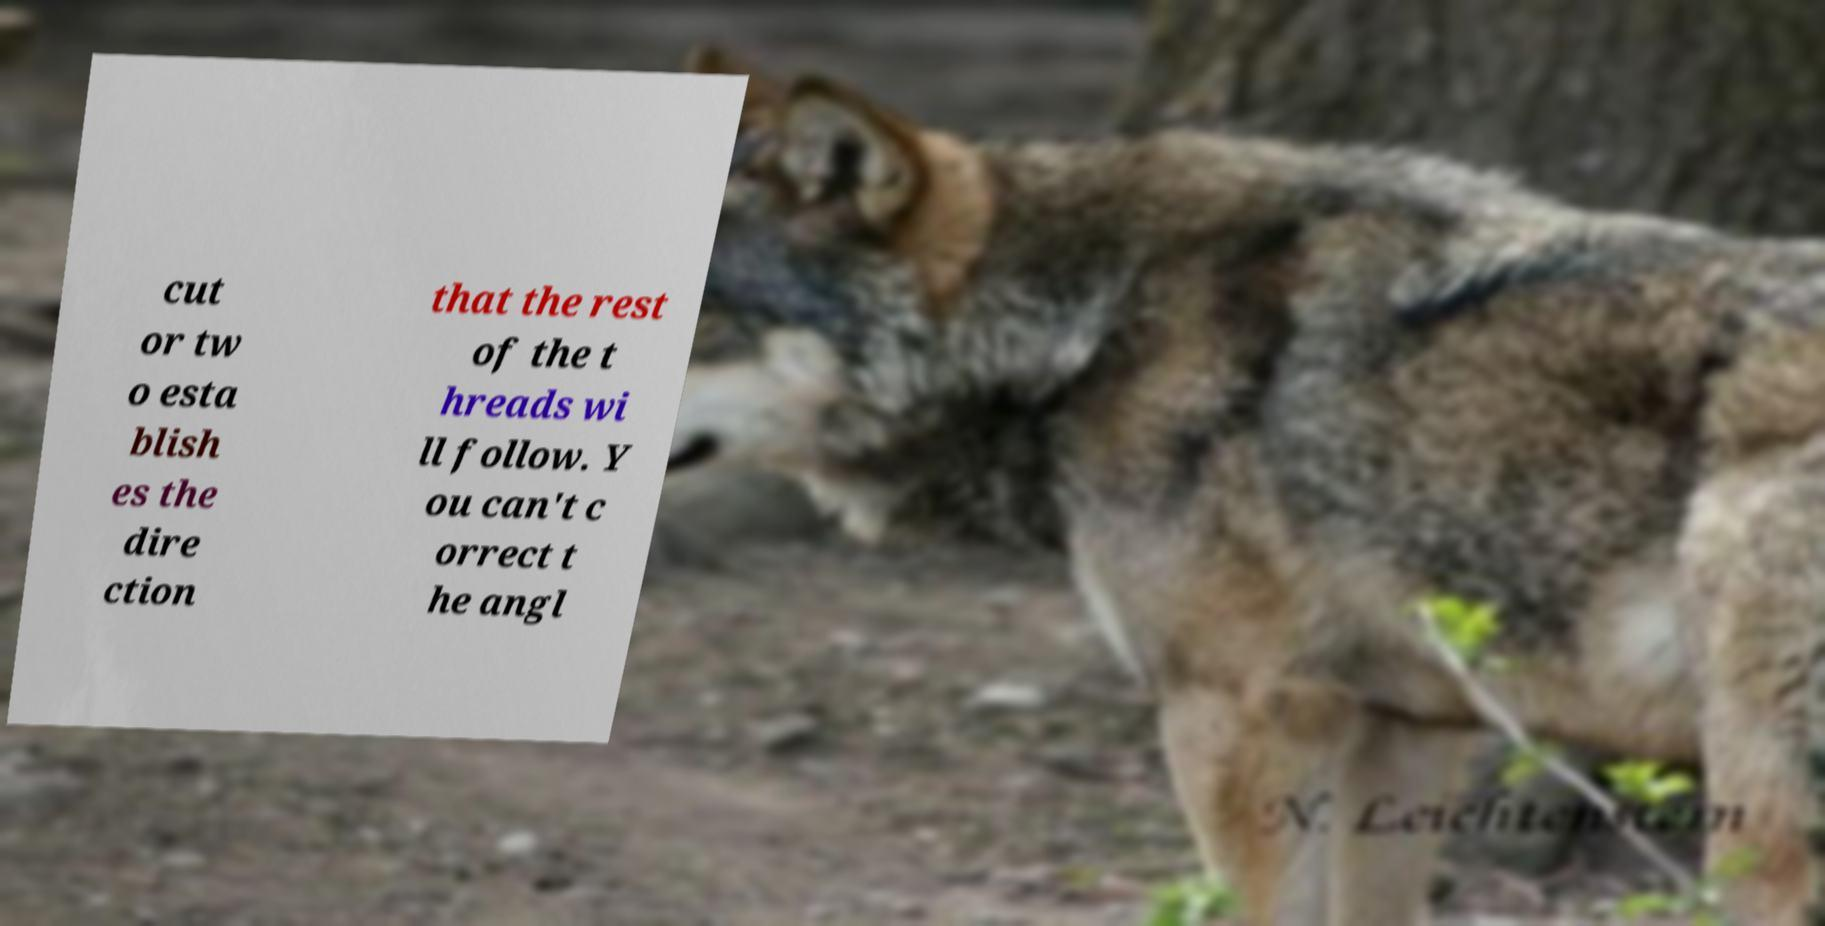For documentation purposes, I need the text within this image transcribed. Could you provide that? cut or tw o esta blish es the dire ction that the rest of the t hreads wi ll follow. Y ou can't c orrect t he angl 